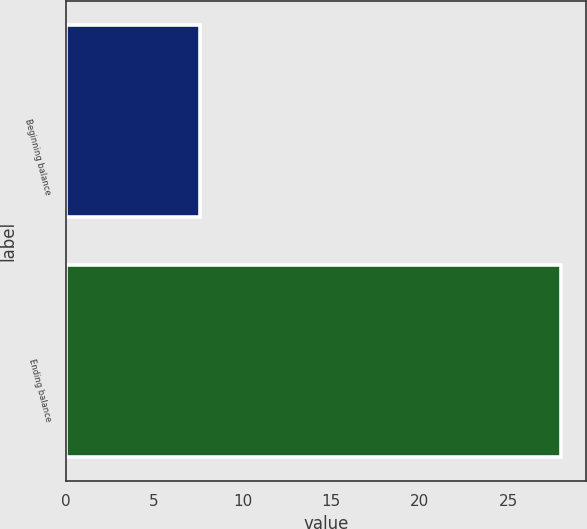<chart> <loc_0><loc_0><loc_500><loc_500><bar_chart><fcel>Beginning balance<fcel>Ending balance<nl><fcel>7.6<fcel>28<nl></chart> 